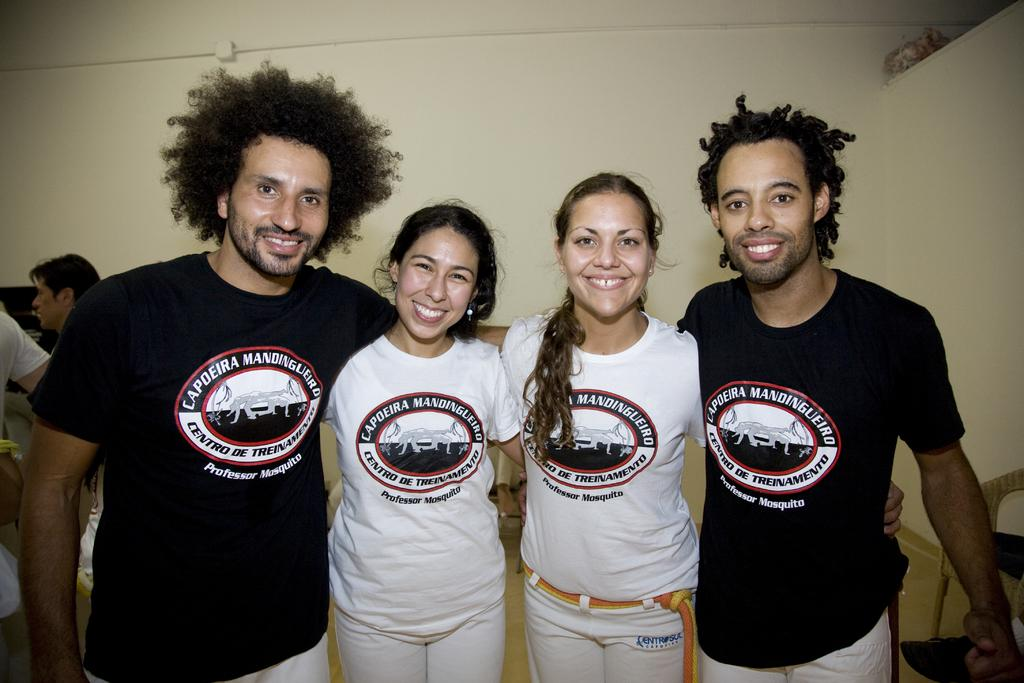Who or what can be seen in the image? There are people in the image. What is visible in the background of the image? There is a wall and unspecified objects in the background of the image. What key is being used to unlock the door in the image? There is no mention of a door or a key in the image. 